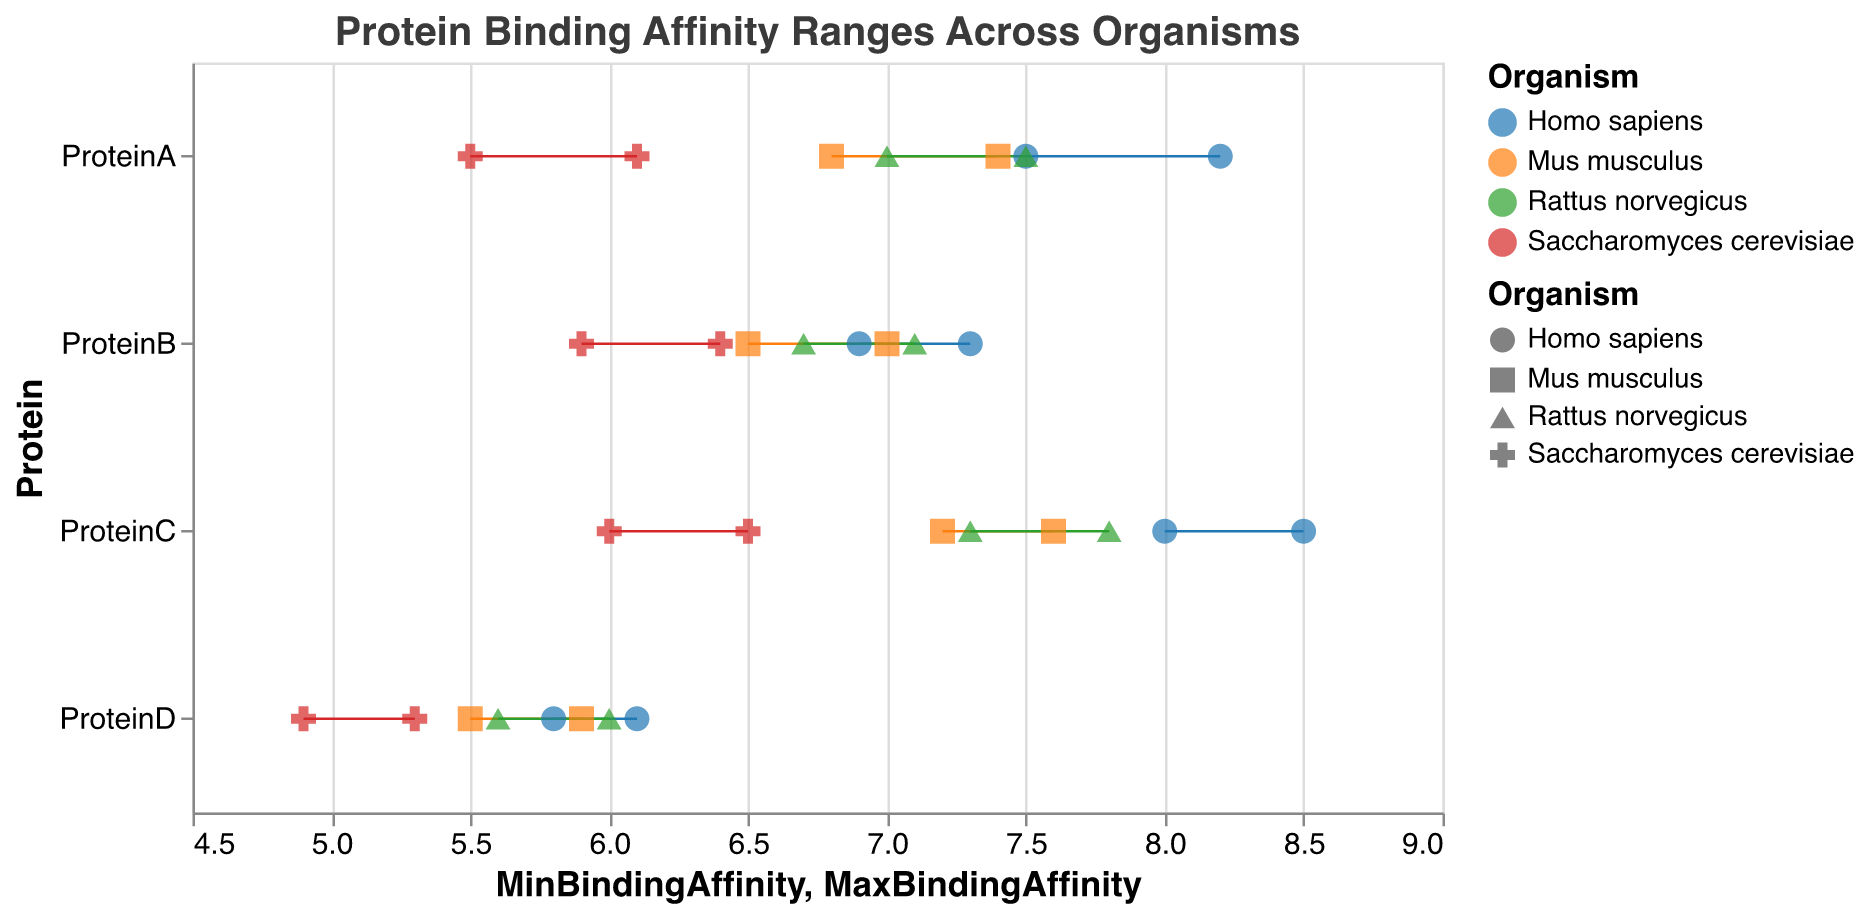What is the title of the plot? The title of the plot is typically displayed at the top and provides an overview of what the figure represents. In this case, it's written as a text element at the top of the figure.
Answer: Protein Binding Affinity Ranges Across Organisms Which protein has the highest maximum binding affinity in Homo sapiens? To find this, look at the maximum binding affinity values for Homo sapiens across all proteins. Protein C has the highest maximum value at 8.5.
Answer: ProteinC What is the range of binding affinity for ProteinD in Mus musculus? The range can be calculated by subtracting the minimum binding affinity from the maximum binding affinity: 5.9 - 5.5 = 0.4.
Answer: 0.4 Which organism has the lowest minimum binding affinity for any protein, and what is that value? Look at the minimum binding affinity values across all organisms and proteins. Saccharomyces cerevisiae has the lowest minimum value for ProteinD at 4.9.
Answer: Saccharomyces cerevisiae, 4.9 For which protein do all organisms have binding affinities above 5.0? Check each protein to ensure that the minimum binding affinity for all organisms is above 5.0. Protein A and Protein B meet this criterion.
Answer: ProteinA, ProteinB Which organisms show the widest range of binding affinities for any protein, and what is that range? Find the organism with the largest difference between minimum and maximum binding affinities for a single protein. Saccharomyces cerevisiae shows the widest range for ProteinC: 6.5 - 6.0 = 0.5.
Answer: Saccharomyces cerevisiae, 0.5 Is there an organism where ProteinD has lower binding affinities than ProteinA? Compare the binding affinity ranges for ProteinD and ProteinA within each organism. For all organisms, the binding affinity range for ProteinD is lower than that for ProteinA.
Answer: Yes, for all organisms How do the binding affinities for ProteinB in Rattus norvegicus compare to those in Mus musculus? Compare the binding affinity ranges. In Rattus norvegicus, the range is 6.7 to 7.1; in Mus musculus, it is 6.5 to 7.0. The binding affinities in Rattus norvegicus are slightly higher.
Answer: Higher in Rattus norvegicus What is the average maximum binding affinity of ProteinC across all organisms? Sum the maximum binding affinities of ProteinC for all organisms and divide by the number of organisms: (8.5 + 7.6 + 7.8 + 6.5) / 4 = 7.6.
Answer: 7.6 